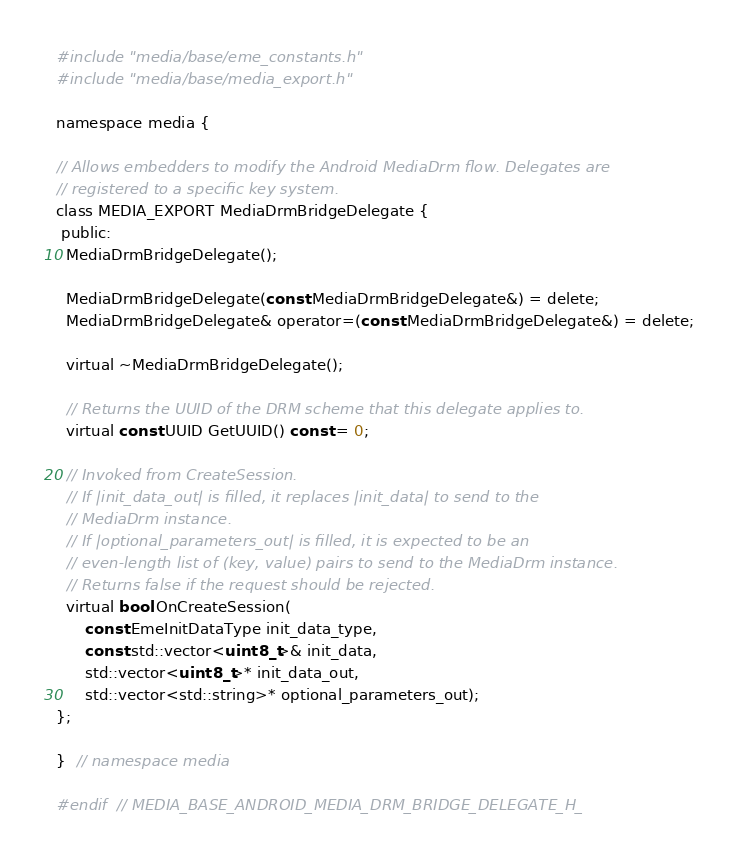<code> <loc_0><loc_0><loc_500><loc_500><_C_>#include "media/base/eme_constants.h"
#include "media/base/media_export.h"

namespace media {

// Allows embedders to modify the Android MediaDrm flow. Delegates are
// registered to a specific key system.
class MEDIA_EXPORT MediaDrmBridgeDelegate {
 public:
  MediaDrmBridgeDelegate();

  MediaDrmBridgeDelegate(const MediaDrmBridgeDelegate&) = delete;
  MediaDrmBridgeDelegate& operator=(const MediaDrmBridgeDelegate&) = delete;

  virtual ~MediaDrmBridgeDelegate();

  // Returns the UUID of the DRM scheme that this delegate applies to.
  virtual const UUID GetUUID() const = 0;

  // Invoked from CreateSession.
  // If |init_data_out| is filled, it replaces |init_data| to send to the
  // MediaDrm instance.
  // If |optional_parameters_out| is filled, it is expected to be an
  // even-length list of (key, value) pairs to send to the MediaDrm instance.
  // Returns false if the request should be rejected.
  virtual bool OnCreateSession(
      const EmeInitDataType init_data_type,
      const std::vector<uint8_t>& init_data,
      std::vector<uint8_t>* init_data_out,
      std::vector<std::string>* optional_parameters_out);
};

}  // namespace media

#endif  // MEDIA_BASE_ANDROID_MEDIA_DRM_BRIDGE_DELEGATE_H_
</code> 